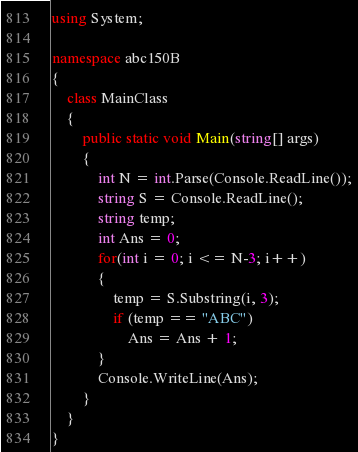<code> <loc_0><loc_0><loc_500><loc_500><_C#_>using System;

namespace abc150B
{
    class MainClass
    {
        public static void Main(string[] args)
        {
            int N = int.Parse(Console.ReadLine());
            string S = Console.ReadLine();
            string temp;
            int Ans = 0;
            for(int i = 0; i <= N-3; i++)
            {
                temp = S.Substring(i, 3);
                if (temp == "ABC")
                    Ans = Ans + 1;
            }
            Console.WriteLine(Ans);
        }
    }
}
</code> 